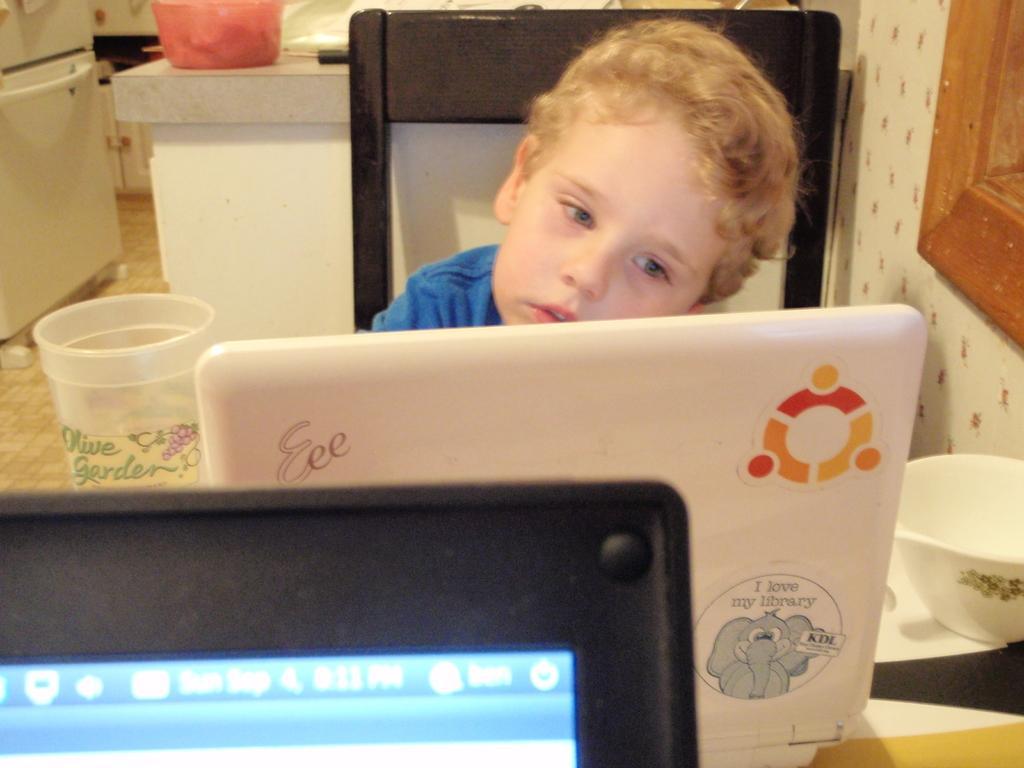Describe this image in one or two sentences. In the image we can see there is a kid sitting on the chair and there are laptops kept on the table. There is a bowl and glass of water kept on the table and behind there is a basket kept on the table. There is a refrigerator kept on the floor. 